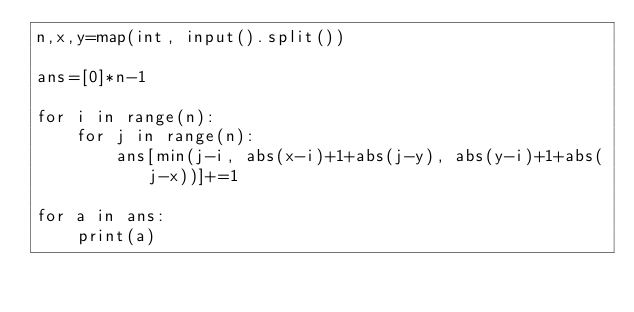Convert code to text. <code><loc_0><loc_0><loc_500><loc_500><_Python_>n,x,y=map(int, input().split())

ans=[0]*n-1

for i in range(n):
    for j in range(n):
        ans[min(j-i, abs(x-i)+1+abs(j-y), abs(y-i)+1+abs(j-x))]+=1

for a in ans:
    print(a)</code> 